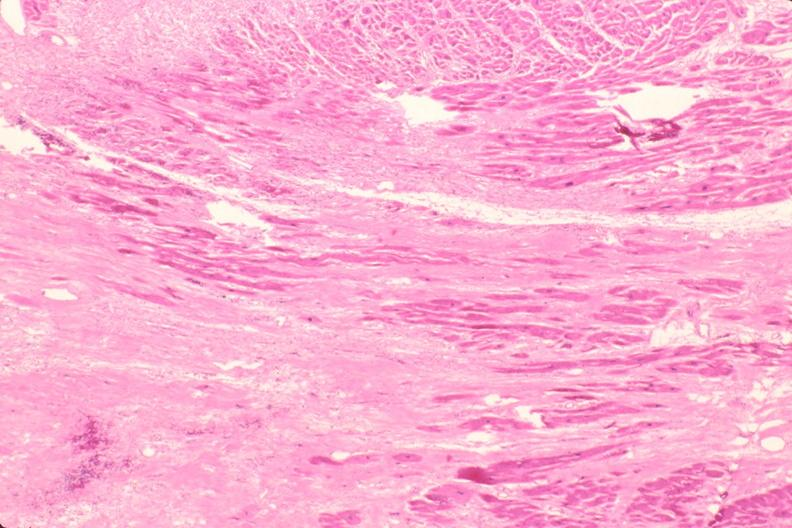where is this in?
Answer the question using a single word or phrase. In heart 